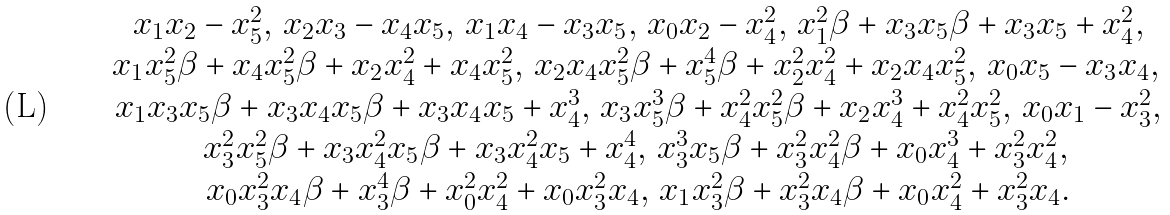Convert formula to latex. <formula><loc_0><loc_0><loc_500><loc_500>\begin{array} { c } x _ { 1 } x _ { 2 } - x _ { 5 } ^ { 2 } , \, x _ { 2 } x _ { 3 } - x _ { 4 } x _ { 5 } , \, x _ { 1 } x _ { 4 } - x _ { 3 } x _ { 5 } , \, x _ { 0 } x _ { 2 } - x _ { 4 } ^ { 2 } , \, x _ { 1 } ^ { 2 } { \beta } + x _ { 3 } x _ { 5 } { \beta } + x _ { 3 } x _ { 5 } + x _ { 4 } ^ { 2 } , \\ x _ { 1 } x _ { 5 } ^ { 2 } { \beta } + x _ { 4 } x _ { 5 } ^ { 2 } { \beta } + x _ { 2 } x _ { 4 } ^ { 2 } + x _ { 4 } x _ { 5 } ^ { 2 } , \, x _ { 2 } x _ { 4 } x _ { 5 } ^ { 2 } { \beta } + x _ { 5 } ^ { 4 } { \beta } + x _ { 2 } ^ { 2 } x _ { 4 } ^ { 2 } + x _ { 2 } x _ { 4 } x _ { 5 } ^ { 2 } , \, x _ { 0 } x _ { 5 } - x _ { 3 } x _ { 4 } , \, \\ x _ { 1 } x _ { 3 } x _ { 5 } { \beta } + x _ { 3 } x _ { 4 } x _ { 5 } { \beta } + x _ { 3 } x _ { 4 } x _ { 5 } + x _ { 4 } ^ { 3 } , \, x _ { 3 } x _ { 5 } ^ { 3 } { \beta } + x _ { 4 } ^ { 2 } x _ { 5 } ^ { 2 } { \beta } + x _ { 2 } x _ { 4 } ^ { 3 } + x _ { 4 } ^ { 2 } x _ { 5 } ^ { 2 } , \, x _ { 0 } x _ { 1 } - x _ { 3 } ^ { 2 } , \\ x _ { 3 } ^ { 2 } x _ { 5 } ^ { 2 } { \beta } + x _ { 3 } x _ { 4 } ^ { 2 } x _ { 5 } { \beta } + x _ { 3 } x _ { 4 } ^ { 2 } x _ { 5 } + x _ { 4 } ^ { 4 } , \, x _ { 3 } ^ { 3 } x _ { 5 } { \beta } + x _ { 3 } ^ { 2 } x _ { 4 } ^ { 2 } { \beta } + x _ { 0 } x _ { 4 } ^ { 3 } + x _ { 3 } ^ { 2 } x _ { 4 } ^ { 2 } , \, \\ x _ { 0 } x _ { 3 } ^ { 2 } x _ { 4 } { \beta } + x _ { 3 } ^ { 4 } { \beta } + x _ { 0 } ^ { 2 } x _ { 4 } ^ { 2 } + x _ { 0 } x _ { 3 } ^ { 2 } x _ { 4 } , \, x _ { 1 } x _ { 3 } ^ { 2 } { \beta } + x _ { 3 } ^ { 2 } x _ { 4 } { \beta } + x _ { 0 } x _ { 4 } ^ { 2 } + x _ { 3 } ^ { 2 } x _ { 4 } . \\ \end{array}</formula> 